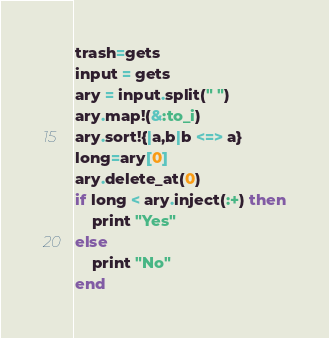<code> <loc_0><loc_0><loc_500><loc_500><_Ruby_>trash=gets
input = gets
ary = input.split(" ")
ary.map!(&:to_i)
ary.sort!{|a,b|b <=> a}
long=ary[0]
ary.delete_at(0)
if long < ary.inject(:+) then
    print "Yes"
else
    print "No"
end</code> 